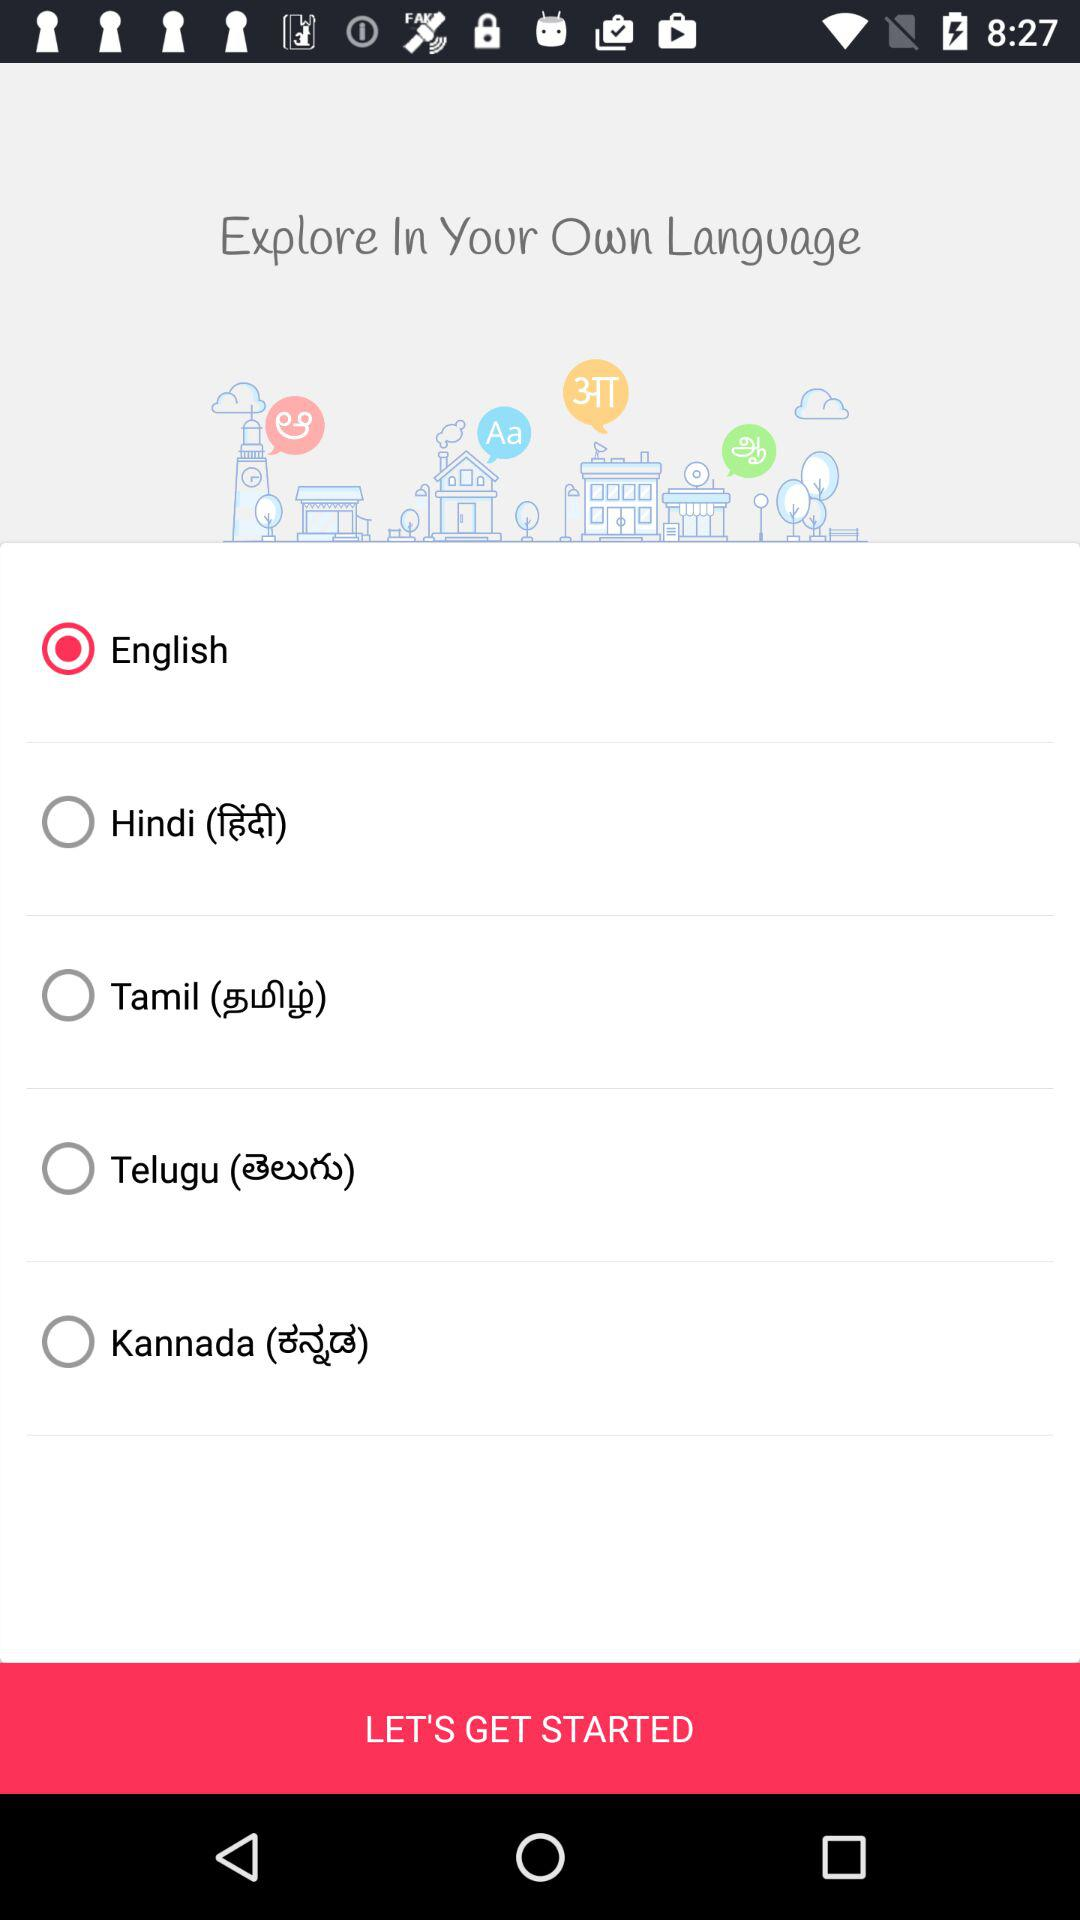What is the selected language? The selected language is English. 